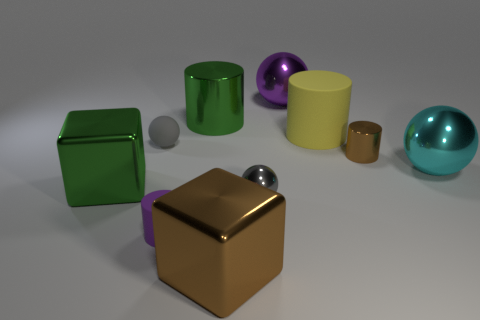The big rubber thing is what color?
Provide a short and direct response. Yellow. There is a gray object that is the same material as the tiny purple cylinder; what is its size?
Provide a succinct answer. Small. There is a tiny cylinder that is the same material as the brown block; what color is it?
Ensure brevity in your answer.  Brown. Is there a rubber object of the same size as the gray rubber ball?
Provide a succinct answer. Yes. There is a big cyan thing that is the same shape as the big purple metal thing; what is it made of?
Keep it short and to the point. Metal. There is a purple object that is the same size as the brown cylinder; what shape is it?
Keep it short and to the point. Cylinder. Is there another large green object that has the same shape as the big rubber object?
Make the answer very short. Yes. What shape is the big green metallic object that is in front of the small gray object left of the brown metallic block?
Your answer should be compact. Cube. There is a tiny brown metallic thing; what shape is it?
Ensure brevity in your answer.  Cylinder. The tiny cylinder that is to the right of the cube to the right of the gray thing that is to the left of the large brown object is made of what material?
Keep it short and to the point. Metal. 